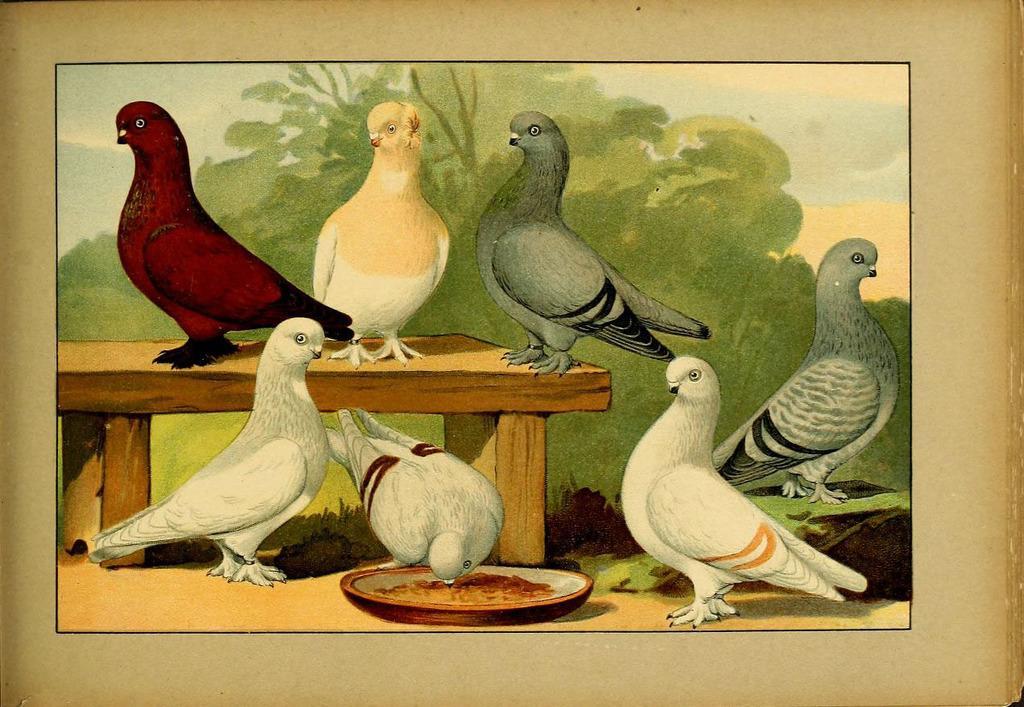Can you describe this image briefly? In this picture there is a painting frame which is placed on the wall. In that painting I can see the different color birds were standing on the table and floor. In the back I can see the trees, plants and grass. In the top right corner of the painting I can see the sky and clouds. At the bottom there are some seeds in a plate. 